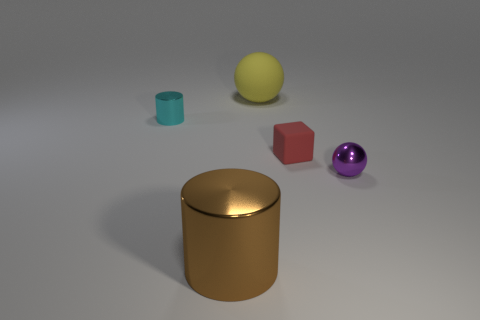There is a tiny metallic object to the right of the small metal thing to the left of the large yellow object; what color is it?
Ensure brevity in your answer.  Purple. Is there a large sphere in front of the tiny metallic thing behind the metallic thing right of the small red matte thing?
Make the answer very short. No. The small cylinder that is the same material as the large cylinder is what color?
Offer a very short reply. Cyan. How many objects have the same material as the tiny cylinder?
Your response must be concise. 2. Are the red thing and the brown cylinder that is left of the red matte object made of the same material?
Offer a terse response. No. What number of objects are either cylinders that are behind the big brown thing or small yellow cubes?
Your answer should be compact. 1. There is a shiny object to the right of the thing that is behind the small shiny thing behind the purple ball; what size is it?
Provide a succinct answer. Small. Are there any other things that are the same shape as the big matte thing?
Make the answer very short. Yes. How big is the object behind the tiny metal object left of the yellow object?
Keep it short and to the point. Large. What number of big things are red rubber blocks or rubber balls?
Offer a terse response. 1. 